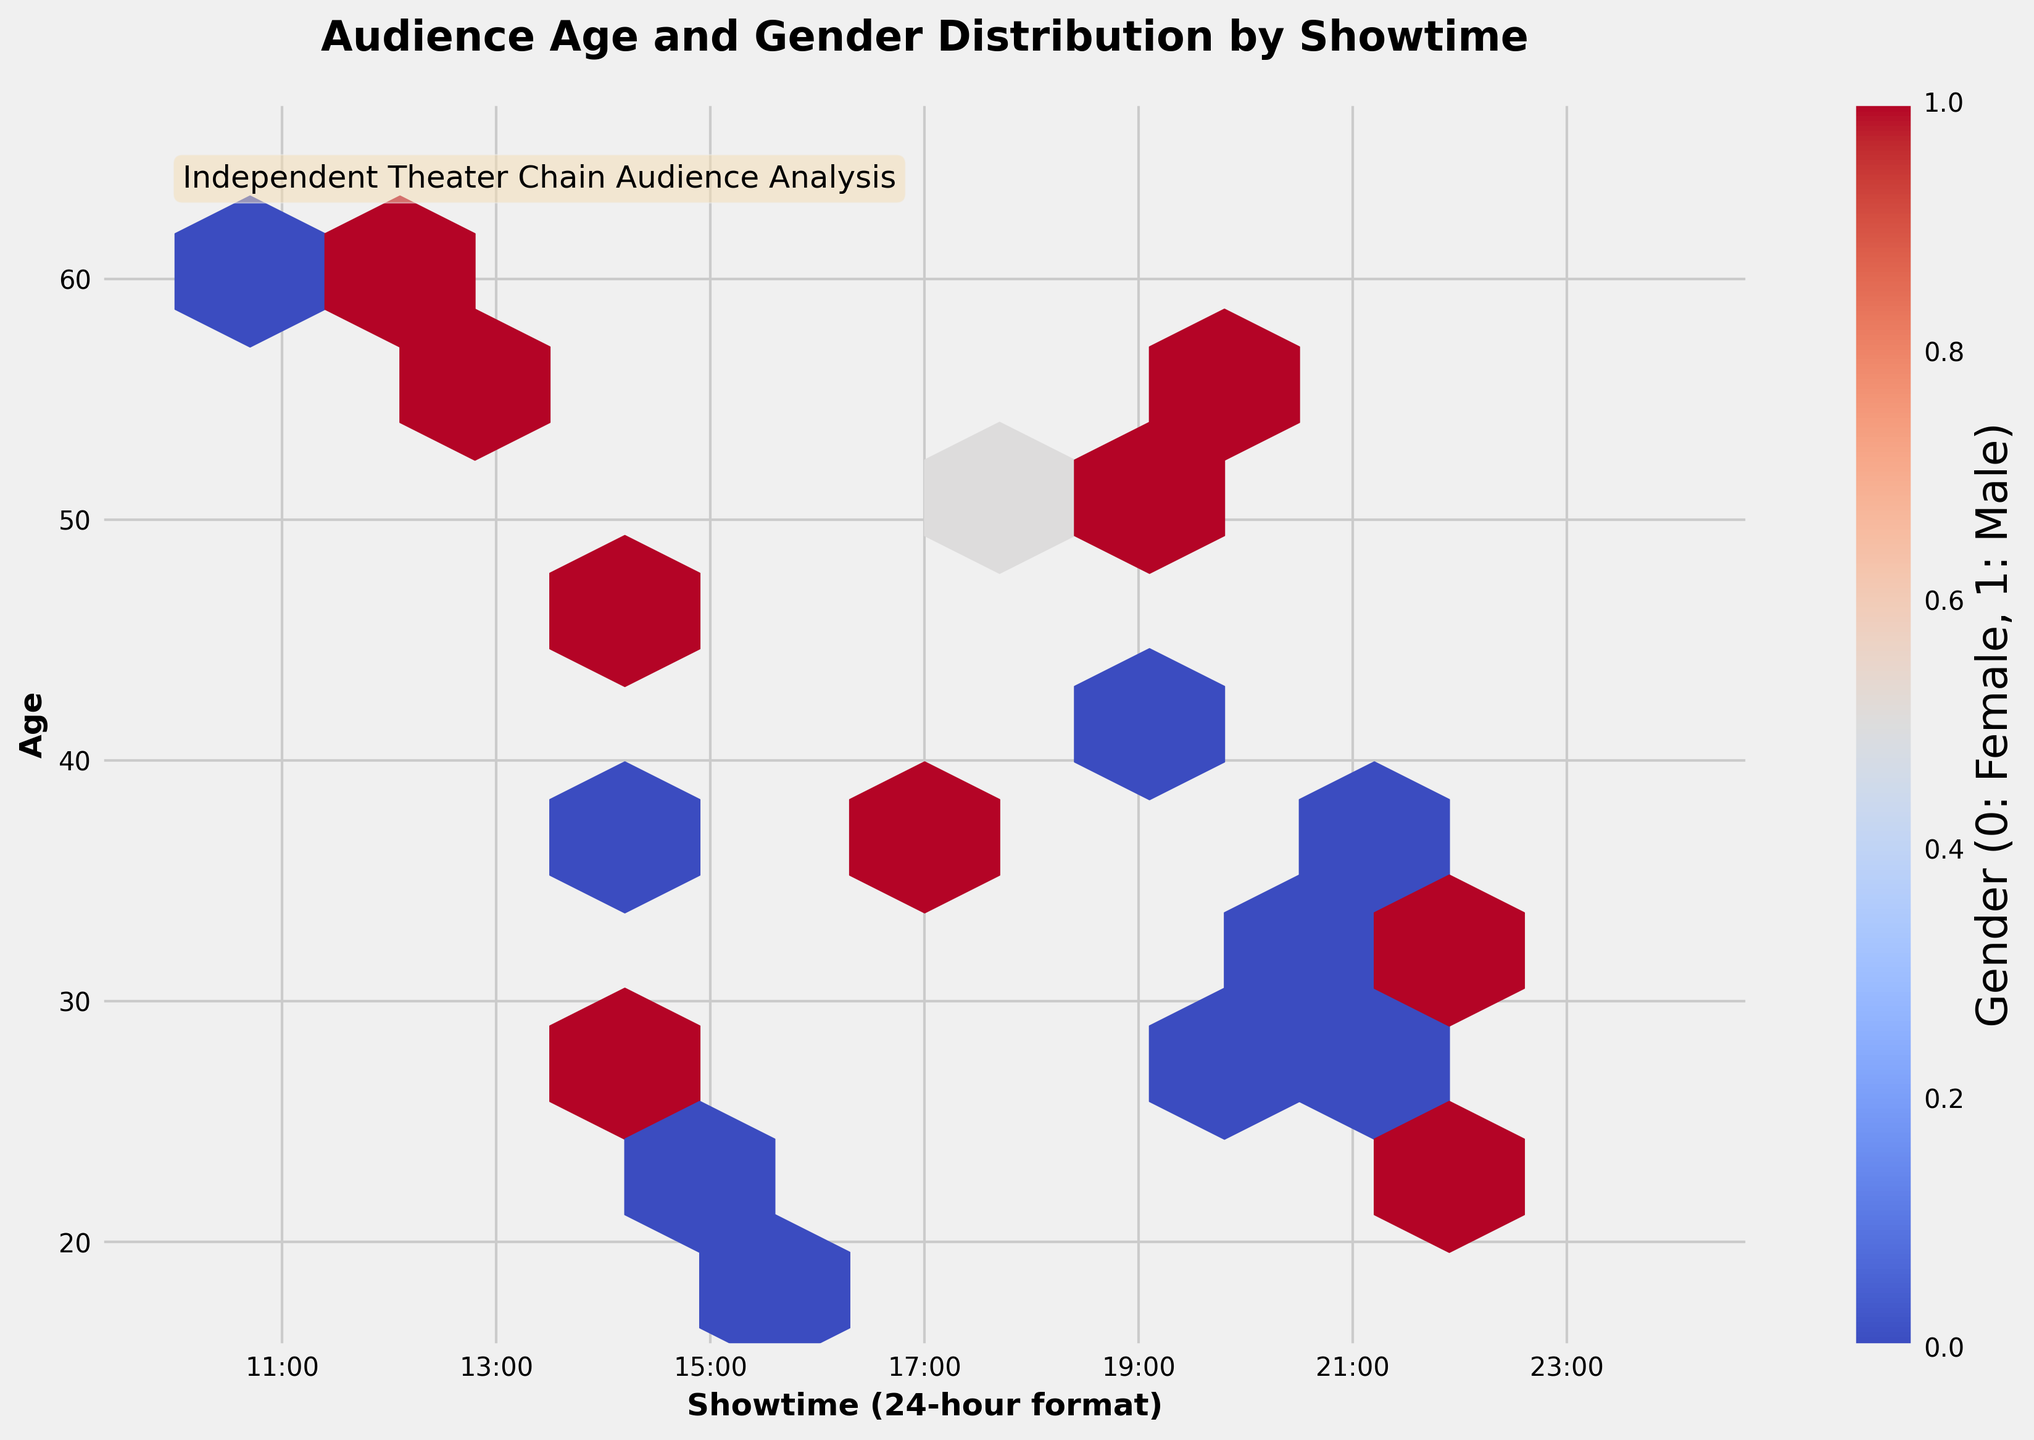How is the gender of the audience represented in the hexbin plot? The gender of the audience is indicated by color. The colormap "coolwarm" ranges from cool colors indicating females (0) to warm colors indicating males (1).
Answer: By color What is the focus of the analysis presented in the plot? The title "Audience Age and Gender Distribution by Showtime" clearly states that the focus is on analyzing the distribution of audience age and gender across different movie showtimes.
Answer: Audience age and gender distribution by showtime What is the age and gender distribution for showtimes starting at 14:00? Referring to the hexbin plot, the color bar helps to identify the gender, and the density and location of the bins show the age distribution. For showtimes starting around 14:00, the plot shows mixed genders with more bins around ages 40-50.
Answer: Mixed genders, ages 40-50 predominantly How does the distribution of males and females differ by showtime? Analyzing the color variations across the plot, males (indicated by warm colors) are more frequent in later showtimes after 18:00, while females (indicated by cool colors) are more common in the earlier showtimes between 10:00 and 18:00.
Answer: Males more frequent after 18:00, females before 18:00 Which time slot shows the highest concentration of audience members? The hexbin plot visual density indicates the highest concentration of points around the 20:00-22:00 time slot, implying more audience members during this period.
Answer: 20:00-22:00 Are younger or older audiences more likely to attend movies earlier in the day? Referring to the hexbin plot, the early showtimes (before 12:00) tend to have older audiences (ages 50 and above) compared to younger audiences (ages 18-30) who appear more frequently at later showtimes.
Answer: Older audiences How are showtimes labeled on the x-axis? The showtimes on the x-axis are presented in a 24-hour format, with labels at two-hour intervals from 11:00 to 23:00.
Answer: 24-hour format, at 2-hour intervals from 11:00 to 23:00 Which gender has a higher representation in showtimes around 20:00? The plot shows a stronger presence of warm colors (indicating males) around the 20:00 time slot, suggesting a higher male representation.
Answer: Males What trend can be observed in the audience age distribution across different showtimes? The audience ages appear to be more varied in the evening showtimes (18:00-22:00), whereas the early showtimes (10:00-14:00) are predominantly attended by older audiences.
Answer: More varied ages in evening, older audiences in early showtimes Is there any showtime where the gender distribution appears balanced? Around 18:00-20:00, the hexbin plot shows a mix of warm and cool colors, indicating a relatively balanced gender distribution.
Answer: 18:00-20:00 